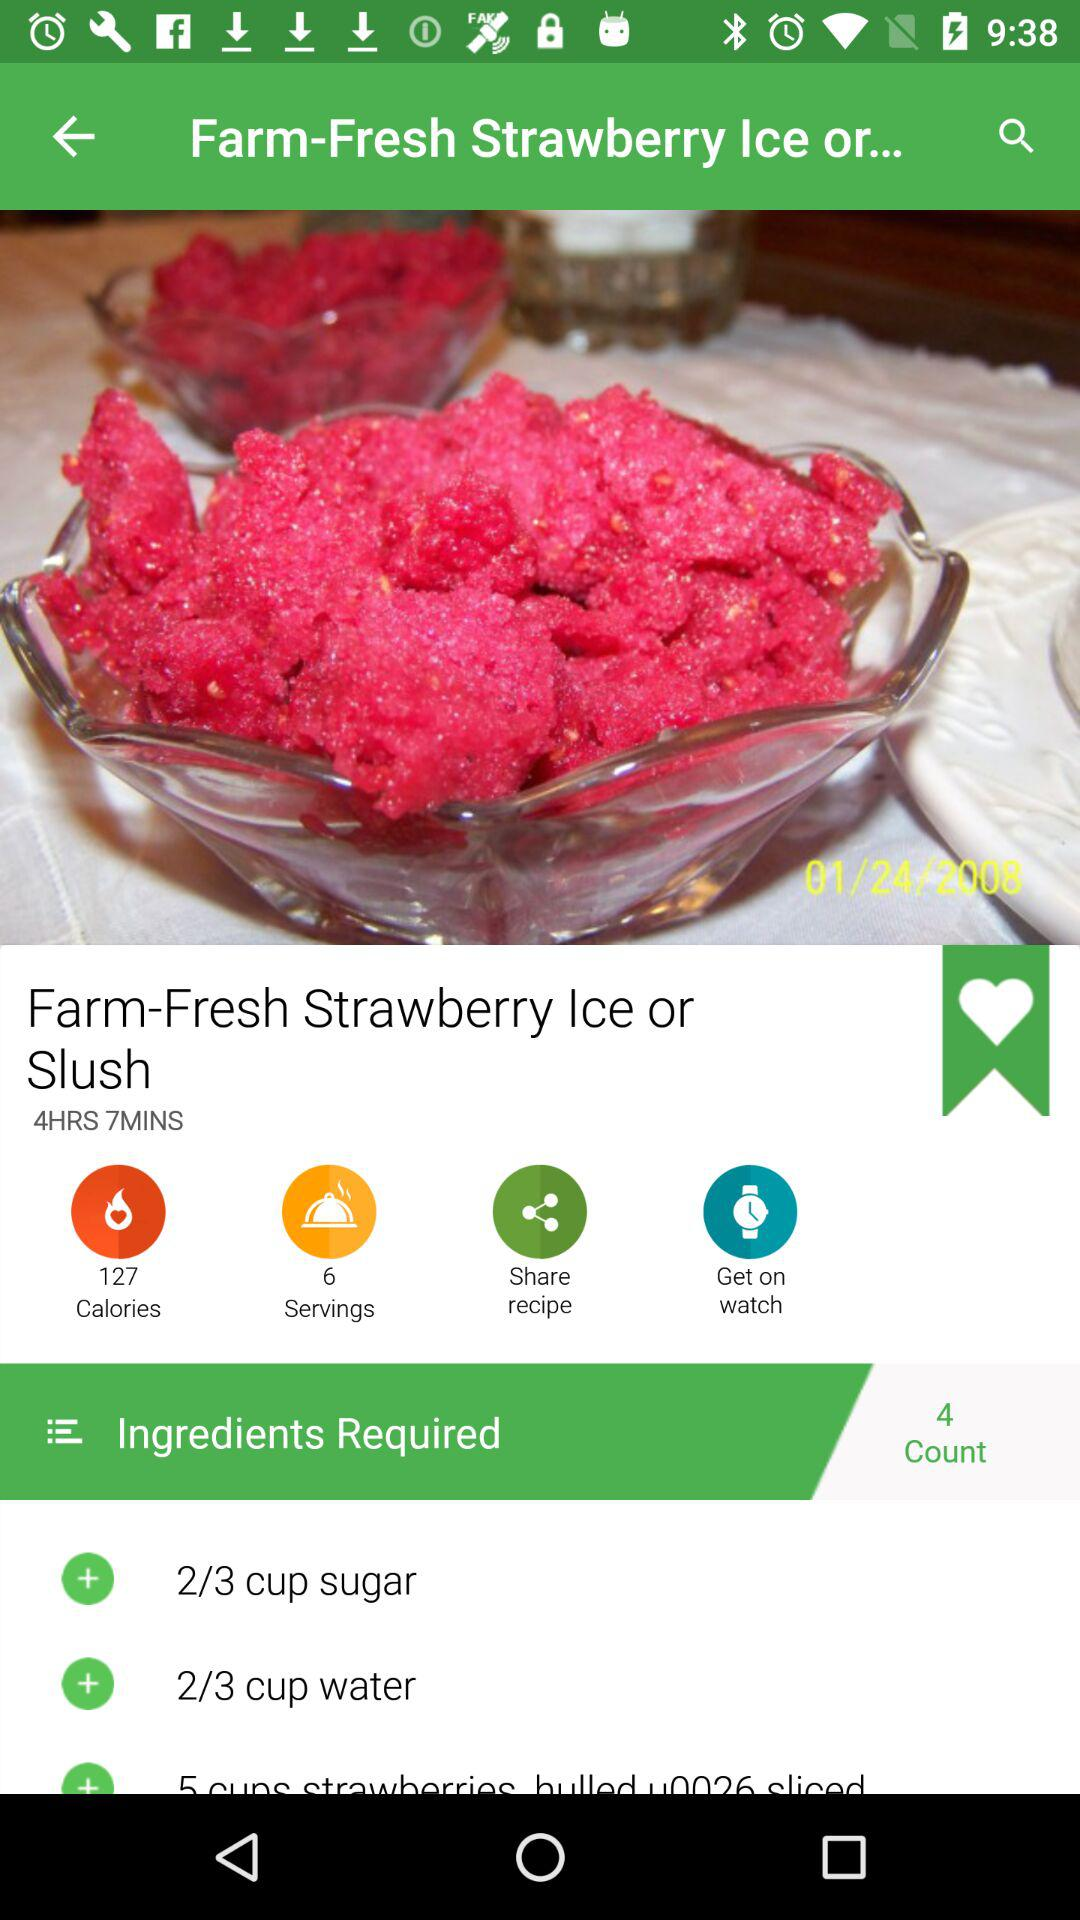How many people can the dish be served to? The dish can be served to 6 people. 